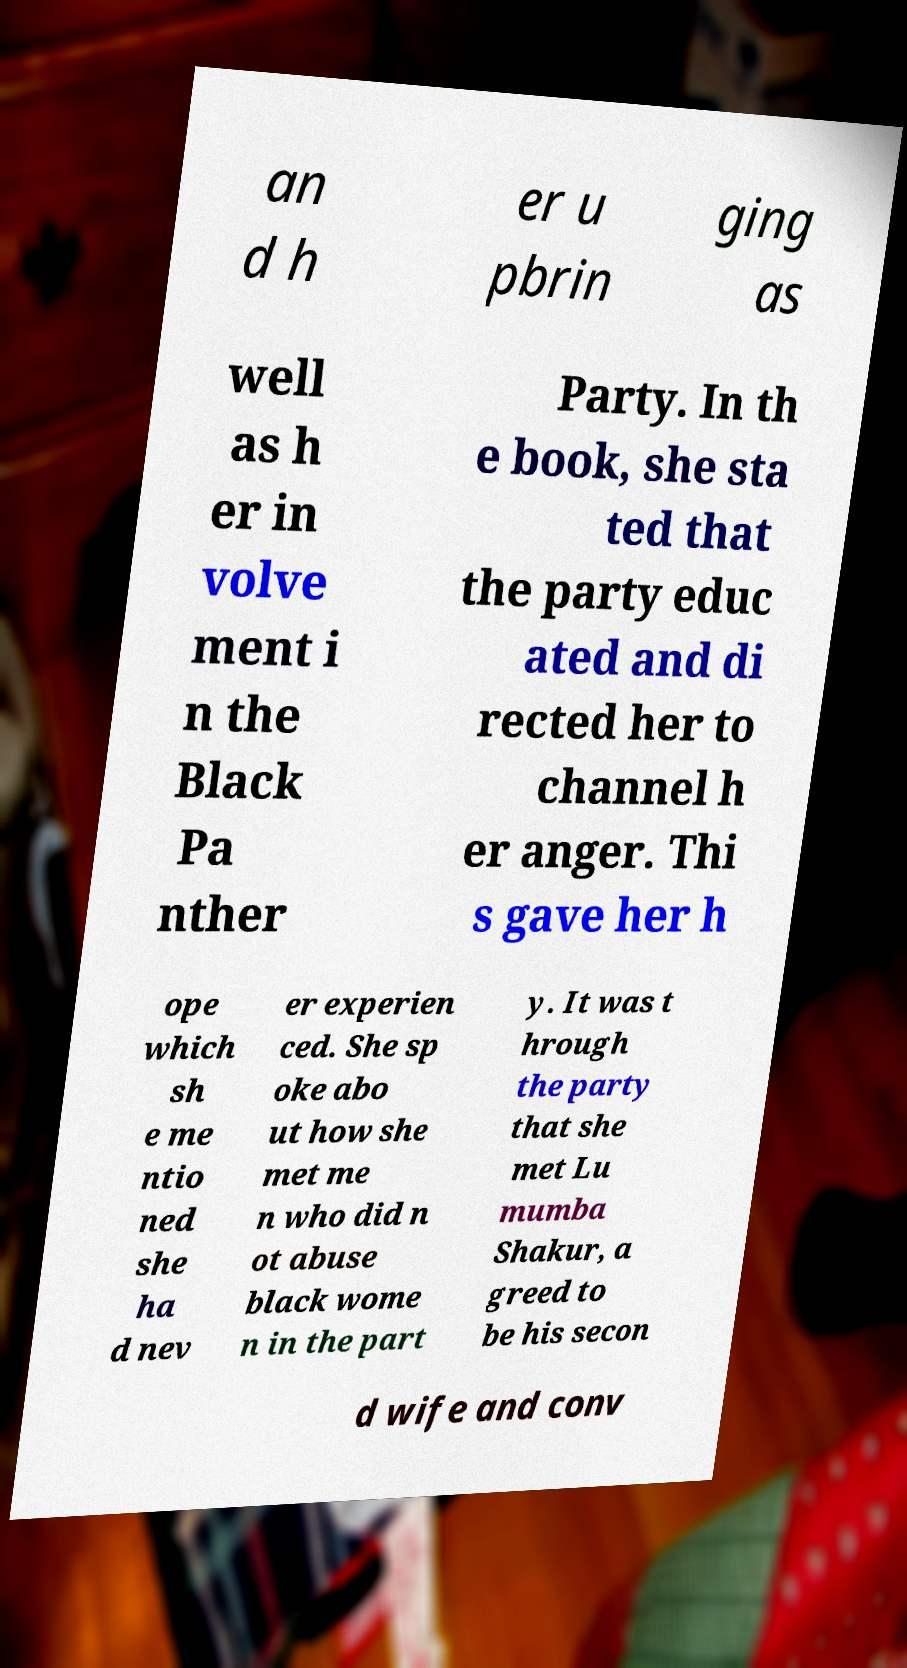There's text embedded in this image that I need extracted. Can you transcribe it verbatim? an d h er u pbrin ging as well as h er in volve ment i n the Black Pa nther Party. In th e book, she sta ted that the party educ ated and di rected her to channel h er anger. Thi s gave her h ope which sh e me ntio ned she ha d nev er experien ced. She sp oke abo ut how she met me n who did n ot abuse black wome n in the part y. It was t hrough the party that she met Lu mumba Shakur, a greed to be his secon d wife and conv 